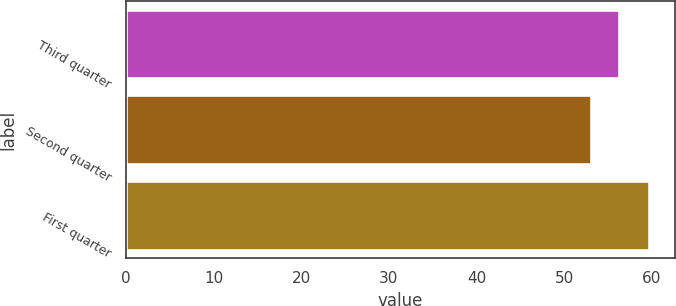<chart> <loc_0><loc_0><loc_500><loc_500><bar_chart><fcel>Third quarter<fcel>Second quarter<fcel>First quarter<nl><fcel>56.32<fcel>53.11<fcel>59.65<nl></chart> 